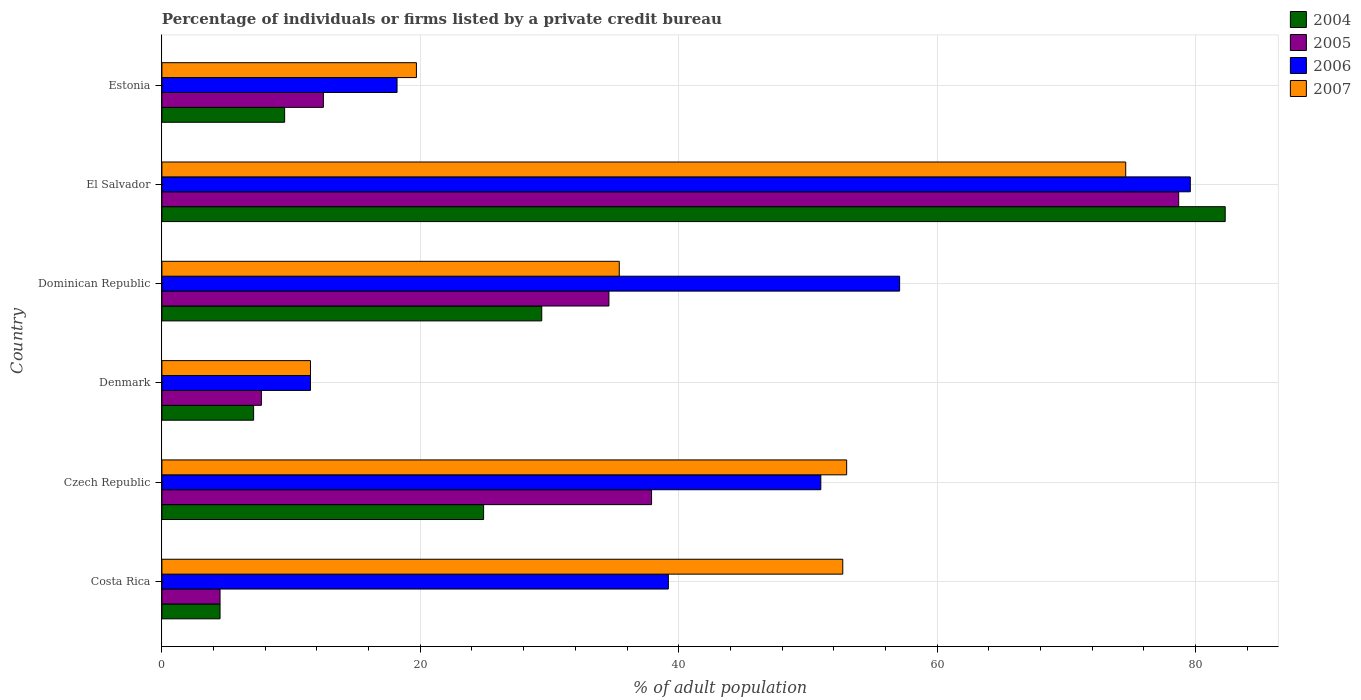Are the number of bars per tick equal to the number of legend labels?
Provide a short and direct response. Yes. How many bars are there on the 1st tick from the top?
Provide a short and direct response. 4. How many bars are there on the 4th tick from the bottom?
Give a very brief answer. 4. What is the label of the 4th group of bars from the top?
Your answer should be compact. Denmark. In how many cases, is the number of bars for a given country not equal to the number of legend labels?
Offer a very short reply. 0. What is the percentage of population listed by a private credit bureau in 2006 in Costa Rica?
Make the answer very short. 39.2. Across all countries, what is the maximum percentage of population listed by a private credit bureau in 2004?
Your response must be concise. 82.3. Across all countries, what is the minimum percentage of population listed by a private credit bureau in 2004?
Your answer should be compact. 4.5. In which country was the percentage of population listed by a private credit bureau in 2006 maximum?
Keep it short and to the point. El Salvador. What is the total percentage of population listed by a private credit bureau in 2004 in the graph?
Give a very brief answer. 157.7. What is the difference between the percentage of population listed by a private credit bureau in 2007 in Czech Republic and that in El Salvador?
Make the answer very short. -21.6. What is the difference between the percentage of population listed by a private credit bureau in 2006 in Dominican Republic and the percentage of population listed by a private credit bureau in 2004 in El Salvador?
Provide a short and direct response. -25.2. What is the average percentage of population listed by a private credit bureau in 2004 per country?
Your answer should be compact. 26.28. What is the ratio of the percentage of population listed by a private credit bureau in 2004 in Dominican Republic to that in Estonia?
Your response must be concise. 3.09. Is the percentage of population listed by a private credit bureau in 2005 in Costa Rica less than that in Czech Republic?
Offer a terse response. Yes. Is the difference between the percentage of population listed by a private credit bureau in 2007 in Denmark and El Salvador greater than the difference between the percentage of population listed by a private credit bureau in 2005 in Denmark and El Salvador?
Your answer should be very brief. Yes. What is the difference between the highest and the second highest percentage of population listed by a private credit bureau in 2007?
Keep it short and to the point. 21.6. What is the difference between the highest and the lowest percentage of population listed by a private credit bureau in 2005?
Provide a short and direct response. 74.2. In how many countries, is the percentage of population listed by a private credit bureau in 2006 greater than the average percentage of population listed by a private credit bureau in 2006 taken over all countries?
Give a very brief answer. 3. Is the sum of the percentage of population listed by a private credit bureau in 2007 in Costa Rica and Denmark greater than the maximum percentage of population listed by a private credit bureau in 2006 across all countries?
Ensure brevity in your answer.  No. Is it the case that in every country, the sum of the percentage of population listed by a private credit bureau in 2006 and percentage of population listed by a private credit bureau in 2004 is greater than the sum of percentage of population listed by a private credit bureau in 2005 and percentage of population listed by a private credit bureau in 2007?
Provide a succinct answer. No. What does the 2nd bar from the top in El Salvador represents?
Offer a terse response. 2006. What does the 2nd bar from the bottom in Czech Republic represents?
Keep it short and to the point. 2005. How many countries are there in the graph?
Give a very brief answer. 6. Does the graph contain grids?
Keep it short and to the point. Yes. Where does the legend appear in the graph?
Give a very brief answer. Top right. How many legend labels are there?
Your answer should be compact. 4. How are the legend labels stacked?
Provide a short and direct response. Vertical. What is the title of the graph?
Provide a succinct answer. Percentage of individuals or firms listed by a private credit bureau. Does "2000" appear as one of the legend labels in the graph?
Offer a terse response. No. What is the label or title of the X-axis?
Give a very brief answer. % of adult population. What is the % of adult population of 2004 in Costa Rica?
Your answer should be compact. 4.5. What is the % of adult population of 2005 in Costa Rica?
Ensure brevity in your answer.  4.5. What is the % of adult population in 2006 in Costa Rica?
Give a very brief answer. 39.2. What is the % of adult population in 2007 in Costa Rica?
Keep it short and to the point. 52.7. What is the % of adult population in 2004 in Czech Republic?
Your response must be concise. 24.9. What is the % of adult population in 2005 in Czech Republic?
Keep it short and to the point. 37.9. What is the % of adult population of 2006 in Czech Republic?
Provide a short and direct response. 51. What is the % of adult population in 2004 in Dominican Republic?
Offer a terse response. 29.4. What is the % of adult population in 2005 in Dominican Republic?
Give a very brief answer. 34.6. What is the % of adult population of 2006 in Dominican Republic?
Your answer should be compact. 57.1. What is the % of adult population of 2007 in Dominican Republic?
Keep it short and to the point. 35.4. What is the % of adult population of 2004 in El Salvador?
Provide a short and direct response. 82.3. What is the % of adult population in 2005 in El Salvador?
Give a very brief answer. 78.7. What is the % of adult population in 2006 in El Salvador?
Your answer should be very brief. 79.6. What is the % of adult population of 2007 in El Salvador?
Keep it short and to the point. 74.6. Across all countries, what is the maximum % of adult population in 2004?
Your answer should be compact. 82.3. Across all countries, what is the maximum % of adult population in 2005?
Your response must be concise. 78.7. Across all countries, what is the maximum % of adult population of 2006?
Your answer should be compact. 79.6. Across all countries, what is the maximum % of adult population of 2007?
Make the answer very short. 74.6. Across all countries, what is the minimum % of adult population of 2004?
Your answer should be compact. 4.5. Across all countries, what is the minimum % of adult population in 2006?
Provide a short and direct response. 11.5. Across all countries, what is the minimum % of adult population in 2007?
Ensure brevity in your answer.  11.5. What is the total % of adult population in 2004 in the graph?
Your response must be concise. 157.7. What is the total % of adult population in 2005 in the graph?
Provide a succinct answer. 175.9. What is the total % of adult population of 2006 in the graph?
Offer a very short reply. 256.6. What is the total % of adult population of 2007 in the graph?
Offer a terse response. 246.9. What is the difference between the % of adult population in 2004 in Costa Rica and that in Czech Republic?
Provide a short and direct response. -20.4. What is the difference between the % of adult population in 2005 in Costa Rica and that in Czech Republic?
Keep it short and to the point. -33.4. What is the difference between the % of adult population of 2006 in Costa Rica and that in Czech Republic?
Your answer should be very brief. -11.8. What is the difference between the % of adult population of 2007 in Costa Rica and that in Czech Republic?
Make the answer very short. -0.3. What is the difference between the % of adult population in 2006 in Costa Rica and that in Denmark?
Keep it short and to the point. 27.7. What is the difference between the % of adult population in 2007 in Costa Rica and that in Denmark?
Provide a succinct answer. 41.2. What is the difference between the % of adult population in 2004 in Costa Rica and that in Dominican Republic?
Provide a succinct answer. -24.9. What is the difference between the % of adult population in 2005 in Costa Rica and that in Dominican Republic?
Make the answer very short. -30.1. What is the difference between the % of adult population in 2006 in Costa Rica and that in Dominican Republic?
Make the answer very short. -17.9. What is the difference between the % of adult population in 2004 in Costa Rica and that in El Salvador?
Give a very brief answer. -77.8. What is the difference between the % of adult population of 2005 in Costa Rica and that in El Salvador?
Offer a very short reply. -74.2. What is the difference between the % of adult population in 2006 in Costa Rica and that in El Salvador?
Give a very brief answer. -40.4. What is the difference between the % of adult population of 2007 in Costa Rica and that in El Salvador?
Ensure brevity in your answer.  -21.9. What is the difference between the % of adult population of 2004 in Costa Rica and that in Estonia?
Ensure brevity in your answer.  -5. What is the difference between the % of adult population in 2005 in Costa Rica and that in Estonia?
Keep it short and to the point. -8. What is the difference between the % of adult population of 2006 in Costa Rica and that in Estonia?
Offer a terse response. 21. What is the difference between the % of adult population of 2007 in Costa Rica and that in Estonia?
Keep it short and to the point. 33. What is the difference between the % of adult population of 2005 in Czech Republic and that in Denmark?
Provide a succinct answer. 30.2. What is the difference between the % of adult population in 2006 in Czech Republic and that in Denmark?
Your answer should be compact. 39.5. What is the difference between the % of adult population in 2007 in Czech Republic and that in Denmark?
Provide a short and direct response. 41.5. What is the difference between the % of adult population of 2004 in Czech Republic and that in Dominican Republic?
Provide a succinct answer. -4.5. What is the difference between the % of adult population of 2005 in Czech Republic and that in Dominican Republic?
Make the answer very short. 3.3. What is the difference between the % of adult population in 2006 in Czech Republic and that in Dominican Republic?
Keep it short and to the point. -6.1. What is the difference between the % of adult population in 2007 in Czech Republic and that in Dominican Republic?
Your answer should be compact. 17.6. What is the difference between the % of adult population in 2004 in Czech Republic and that in El Salvador?
Your response must be concise. -57.4. What is the difference between the % of adult population in 2005 in Czech Republic and that in El Salvador?
Offer a terse response. -40.8. What is the difference between the % of adult population in 2006 in Czech Republic and that in El Salvador?
Offer a terse response. -28.6. What is the difference between the % of adult population of 2007 in Czech Republic and that in El Salvador?
Offer a very short reply. -21.6. What is the difference between the % of adult population of 2005 in Czech Republic and that in Estonia?
Your answer should be compact. 25.4. What is the difference between the % of adult population in 2006 in Czech Republic and that in Estonia?
Offer a very short reply. 32.8. What is the difference between the % of adult population in 2007 in Czech Republic and that in Estonia?
Make the answer very short. 33.3. What is the difference between the % of adult population of 2004 in Denmark and that in Dominican Republic?
Your response must be concise. -22.3. What is the difference between the % of adult population of 2005 in Denmark and that in Dominican Republic?
Your response must be concise. -26.9. What is the difference between the % of adult population of 2006 in Denmark and that in Dominican Republic?
Provide a short and direct response. -45.6. What is the difference between the % of adult population in 2007 in Denmark and that in Dominican Republic?
Provide a succinct answer. -23.9. What is the difference between the % of adult population of 2004 in Denmark and that in El Salvador?
Offer a very short reply. -75.2. What is the difference between the % of adult population of 2005 in Denmark and that in El Salvador?
Give a very brief answer. -71. What is the difference between the % of adult population of 2006 in Denmark and that in El Salvador?
Make the answer very short. -68.1. What is the difference between the % of adult population in 2007 in Denmark and that in El Salvador?
Provide a short and direct response. -63.1. What is the difference between the % of adult population of 2005 in Denmark and that in Estonia?
Your answer should be compact. -4.8. What is the difference between the % of adult population in 2006 in Denmark and that in Estonia?
Offer a terse response. -6.7. What is the difference between the % of adult population in 2007 in Denmark and that in Estonia?
Offer a terse response. -8.2. What is the difference between the % of adult population of 2004 in Dominican Republic and that in El Salvador?
Provide a short and direct response. -52.9. What is the difference between the % of adult population of 2005 in Dominican Republic and that in El Salvador?
Provide a succinct answer. -44.1. What is the difference between the % of adult population in 2006 in Dominican Republic and that in El Salvador?
Make the answer very short. -22.5. What is the difference between the % of adult population of 2007 in Dominican Republic and that in El Salvador?
Your answer should be very brief. -39.2. What is the difference between the % of adult population of 2005 in Dominican Republic and that in Estonia?
Provide a succinct answer. 22.1. What is the difference between the % of adult population of 2006 in Dominican Republic and that in Estonia?
Offer a very short reply. 38.9. What is the difference between the % of adult population of 2007 in Dominican Republic and that in Estonia?
Offer a terse response. 15.7. What is the difference between the % of adult population in 2004 in El Salvador and that in Estonia?
Keep it short and to the point. 72.8. What is the difference between the % of adult population in 2005 in El Salvador and that in Estonia?
Your answer should be very brief. 66.2. What is the difference between the % of adult population in 2006 in El Salvador and that in Estonia?
Ensure brevity in your answer.  61.4. What is the difference between the % of adult population of 2007 in El Salvador and that in Estonia?
Give a very brief answer. 54.9. What is the difference between the % of adult population of 2004 in Costa Rica and the % of adult population of 2005 in Czech Republic?
Your answer should be compact. -33.4. What is the difference between the % of adult population in 2004 in Costa Rica and the % of adult population in 2006 in Czech Republic?
Make the answer very short. -46.5. What is the difference between the % of adult population in 2004 in Costa Rica and the % of adult population in 2007 in Czech Republic?
Your answer should be very brief. -48.5. What is the difference between the % of adult population in 2005 in Costa Rica and the % of adult population in 2006 in Czech Republic?
Offer a very short reply. -46.5. What is the difference between the % of adult population in 2005 in Costa Rica and the % of adult population in 2007 in Czech Republic?
Provide a short and direct response. -48.5. What is the difference between the % of adult population of 2006 in Costa Rica and the % of adult population of 2007 in Czech Republic?
Your response must be concise. -13.8. What is the difference between the % of adult population of 2004 in Costa Rica and the % of adult population of 2005 in Denmark?
Ensure brevity in your answer.  -3.2. What is the difference between the % of adult population in 2004 in Costa Rica and the % of adult population in 2006 in Denmark?
Provide a succinct answer. -7. What is the difference between the % of adult population in 2004 in Costa Rica and the % of adult population in 2007 in Denmark?
Make the answer very short. -7. What is the difference between the % of adult population of 2005 in Costa Rica and the % of adult population of 2006 in Denmark?
Keep it short and to the point. -7. What is the difference between the % of adult population of 2006 in Costa Rica and the % of adult population of 2007 in Denmark?
Keep it short and to the point. 27.7. What is the difference between the % of adult population in 2004 in Costa Rica and the % of adult population in 2005 in Dominican Republic?
Provide a succinct answer. -30.1. What is the difference between the % of adult population of 2004 in Costa Rica and the % of adult population of 2006 in Dominican Republic?
Ensure brevity in your answer.  -52.6. What is the difference between the % of adult population in 2004 in Costa Rica and the % of adult population in 2007 in Dominican Republic?
Provide a short and direct response. -30.9. What is the difference between the % of adult population in 2005 in Costa Rica and the % of adult population in 2006 in Dominican Republic?
Ensure brevity in your answer.  -52.6. What is the difference between the % of adult population of 2005 in Costa Rica and the % of adult population of 2007 in Dominican Republic?
Give a very brief answer. -30.9. What is the difference between the % of adult population of 2004 in Costa Rica and the % of adult population of 2005 in El Salvador?
Give a very brief answer. -74.2. What is the difference between the % of adult population in 2004 in Costa Rica and the % of adult population in 2006 in El Salvador?
Provide a succinct answer. -75.1. What is the difference between the % of adult population in 2004 in Costa Rica and the % of adult population in 2007 in El Salvador?
Keep it short and to the point. -70.1. What is the difference between the % of adult population of 2005 in Costa Rica and the % of adult population of 2006 in El Salvador?
Give a very brief answer. -75.1. What is the difference between the % of adult population of 2005 in Costa Rica and the % of adult population of 2007 in El Salvador?
Make the answer very short. -70.1. What is the difference between the % of adult population in 2006 in Costa Rica and the % of adult population in 2007 in El Salvador?
Ensure brevity in your answer.  -35.4. What is the difference between the % of adult population in 2004 in Costa Rica and the % of adult population in 2005 in Estonia?
Give a very brief answer. -8. What is the difference between the % of adult population in 2004 in Costa Rica and the % of adult population in 2006 in Estonia?
Ensure brevity in your answer.  -13.7. What is the difference between the % of adult population in 2004 in Costa Rica and the % of adult population in 2007 in Estonia?
Your response must be concise. -15.2. What is the difference between the % of adult population of 2005 in Costa Rica and the % of adult population of 2006 in Estonia?
Provide a succinct answer. -13.7. What is the difference between the % of adult population of 2005 in Costa Rica and the % of adult population of 2007 in Estonia?
Your response must be concise. -15.2. What is the difference between the % of adult population of 2006 in Costa Rica and the % of adult population of 2007 in Estonia?
Provide a short and direct response. 19.5. What is the difference between the % of adult population in 2004 in Czech Republic and the % of adult population in 2005 in Denmark?
Provide a short and direct response. 17.2. What is the difference between the % of adult population in 2004 in Czech Republic and the % of adult population in 2006 in Denmark?
Ensure brevity in your answer.  13.4. What is the difference between the % of adult population in 2004 in Czech Republic and the % of adult population in 2007 in Denmark?
Offer a very short reply. 13.4. What is the difference between the % of adult population in 2005 in Czech Republic and the % of adult population in 2006 in Denmark?
Provide a short and direct response. 26.4. What is the difference between the % of adult population in 2005 in Czech Republic and the % of adult population in 2007 in Denmark?
Provide a short and direct response. 26.4. What is the difference between the % of adult population in 2006 in Czech Republic and the % of adult population in 2007 in Denmark?
Offer a terse response. 39.5. What is the difference between the % of adult population in 2004 in Czech Republic and the % of adult population in 2005 in Dominican Republic?
Your answer should be very brief. -9.7. What is the difference between the % of adult population in 2004 in Czech Republic and the % of adult population in 2006 in Dominican Republic?
Provide a succinct answer. -32.2. What is the difference between the % of adult population in 2004 in Czech Republic and the % of adult population in 2007 in Dominican Republic?
Provide a succinct answer. -10.5. What is the difference between the % of adult population in 2005 in Czech Republic and the % of adult population in 2006 in Dominican Republic?
Offer a very short reply. -19.2. What is the difference between the % of adult population of 2006 in Czech Republic and the % of adult population of 2007 in Dominican Republic?
Give a very brief answer. 15.6. What is the difference between the % of adult population in 2004 in Czech Republic and the % of adult population in 2005 in El Salvador?
Give a very brief answer. -53.8. What is the difference between the % of adult population in 2004 in Czech Republic and the % of adult population in 2006 in El Salvador?
Your response must be concise. -54.7. What is the difference between the % of adult population of 2004 in Czech Republic and the % of adult population of 2007 in El Salvador?
Your answer should be compact. -49.7. What is the difference between the % of adult population of 2005 in Czech Republic and the % of adult population of 2006 in El Salvador?
Offer a very short reply. -41.7. What is the difference between the % of adult population of 2005 in Czech Republic and the % of adult population of 2007 in El Salvador?
Your answer should be very brief. -36.7. What is the difference between the % of adult population of 2006 in Czech Republic and the % of adult population of 2007 in El Salvador?
Provide a short and direct response. -23.6. What is the difference between the % of adult population of 2004 in Czech Republic and the % of adult population of 2005 in Estonia?
Ensure brevity in your answer.  12.4. What is the difference between the % of adult population in 2004 in Czech Republic and the % of adult population in 2007 in Estonia?
Your response must be concise. 5.2. What is the difference between the % of adult population in 2005 in Czech Republic and the % of adult population in 2006 in Estonia?
Give a very brief answer. 19.7. What is the difference between the % of adult population in 2006 in Czech Republic and the % of adult population in 2007 in Estonia?
Offer a terse response. 31.3. What is the difference between the % of adult population of 2004 in Denmark and the % of adult population of 2005 in Dominican Republic?
Your response must be concise. -27.5. What is the difference between the % of adult population in 2004 in Denmark and the % of adult population in 2007 in Dominican Republic?
Offer a very short reply. -28.3. What is the difference between the % of adult population of 2005 in Denmark and the % of adult population of 2006 in Dominican Republic?
Make the answer very short. -49.4. What is the difference between the % of adult population in 2005 in Denmark and the % of adult population in 2007 in Dominican Republic?
Give a very brief answer. -27.7. What is the difference between the % of adult population of 2006 in Denmark and the % of adult population of 2007 in Dominican Republic?
Ensure brevity in your answer.  -23.9. What is the difference between the % of adult population in 2004 in Denmark and the % of adult population in 2005 in El Salvador?
Keep it short and to the point. -71.6. What is the difference between the % of adult population of 2004 in Denmark and the % of adult population of 2006 in El Salvador?
Make the answer very short. -72.5. What is the difference between the % of adult population of 2004 in Denmark and the % of adult population of 2007 in El Salvador?
Ensure brevity in your answer.  -67.5. What is the difference between the % of adult population of 2005 in Denmark and the % of adult population of 2006 in El Salvador?
Make the answer very short. -71.9. What is the difference between the % of adult population of 2005 in Denmark and the % of adult population of 2007 in El Salvador?
Offer a very short reply. -66.9. What is the difference between the % of adult population in 2006 in Denmark and the % of adult population in 2007 in El Salvador?
Make the answer very short. -63.1. What is the difference between the % of adult population in 2005 in Denmark and the % of adult population in 2006 in Estonia?
Your response must be concise. -10.5. What is the difference between the % of adult population in 2005 in Denmark and the % of adult population in 2007 in Estonia?
Offer a very short reply. -12. What is the difference between the % of adult population in 2006 in Denmark and the % of adult population in 2007 in Estonia?
Offer a terse response. -8.2. What is the difference between the % of adult population in 2004 in Dominican Republic and the % of adult population in 2005 in El Salvador?
Provide a succinct answer. -49.3. What is the difference between the % of adult population in 2004 in Dominican Republic and the % of adult population in 2006 in El Salvador?
Provide a succinct answer. -50.2. What is the difference between the % of adult population of 2004 in Dominican Republic and the % of adult population of 2007 in El Salvador?
Your answer should be very brief. -45.2. What is the difference between the % of adult population in 2005 in Dominican Republic and the % of adult population in 2006 in El Salvador?
Make the answer very short. -45. What is the difference between the % of adult population of 2005 in Dominican Republic and the % of adult population of 2007 in El Salvador?
Offer a terse response. -40. What is the difference between the % of adult population in 2006 in Dominican Republic and the % of adult population in 2007 in El Salvador?
Make the answer very short. -17.5. What is the difference between the % of adult population in 2004 in Dominican Republic and the % of adult population in 2005 in Estonia?
Offer a very short reply. 16.9. What is the difference between the % of adult population of 2004 in Dominican Republic and the % of adult population of 2007 in Estonia?
Provide a succinct answer. 9.7. What is the difference between the % of adult population of 2006 in Dominican Republic and the % of adult population of 2007 in Estonia?
Your answer should be very brief. 37.4. What is the difference between the % of adult population in 2004 in El Salvador and the % of adult population in 2005 in Estonia?
Provide a succinct answer. 69.8. What is the difference between the % of adult population in 2004 in El Salvador and the % of adult population in 2006 in Estonia?
Your answer should be compact. 64.1. What is the difference between the % of adult population in 2004 in El Salvador and the % of adult population in 2007 in Estonia?
Provide a succinct answer. 62.6. What is the difference between the % of adult population of 2005 in El Salvador and the % of adult population of 2006 in Estonia?
Make the answer very short. 60.5. What is the difference between the % of adult population of 2006 in El Salvador and the % of adult population of 2007 in Estonia?
Give a very brief answer. 59.9. What is the average % of adult population of 2004 per country?
Provide a succinct answer. 26.28. What is the average % of adult population of 2005 per country?
Make the answer very short. 29.32. What is the average % of adult population of 2006 per country?
Your answer should be very brief. 42.77. What is the average % of adult population in 2007 per country?
Provide a short and direct response. 41.15. What is the difference between the % of adult population of 2004 and % of adult population of 2006 in Costa Rica?
Provide a succinct answer. -34.7. What is the difference between the % of adult population in 2004 and % of adult population in 2007 in Costa Rica?
Ensure brevity in your answer.  -48.2. What is the difference between the % of adult population of 2005 and % of adult population of 2006 in Costa Rica?
Provide a succinct answer. -34.7. What is the difference between the % of adult population of 2005 and % of adult population of 2007 in Costa Rica?
Keep it short and to the point. -48.2. What is the difference between the % of adult population in 2006 and % of adult population in 2007 in Costa Rica?
Make the answer very short. -13.5. What is the difference between the % of adult population in 2004 and % of adult population in 2006 in Czech Republic?
Offer a very short reply. -26.1. What is the difference between the % of adult population in 2004 and % of adult population in 2007 in Czech Republic?
Provide a short and direct response. -28.1. What is the difference between the % of adult population of 2005 and % of adult population of 2006 in Czech Republic?
Your answer should be very brief. -13.1. What is the difference between the % of adult population in 2005 and % of adult population in 2007 in Czech Republic?
Provide a succinct answer. -15.1. What is the difference between the % of adult population of 2005 and % of adult population of 2006 in Denmark?
Provide a succinct answer. -3.8. What is the difference between the % of adult population of 2005 and % of adult population of 2007 in Denmark?
Your response must be concise. -3.8. What is the difference between the % of adult population of 2006 and % of adult population of 2007 in Denmark?
Provide a short and direct response. 0. What is the difference between the % of adult population in 2004 and % of adult population in 2006 in Dominican Republic?
Your answer should be very brief. -27.7. What is the difference between the % of adult population in 2004 and % of adult population in 2007 in Dominican Republic?
Your answer should be compact. -6. What is the difference between the % of adult population of 2005 and % of adult population of 2006 in Dominican Republic?
Provide a short and direct response. -22.5. What is the difference between the % of adult population of 2005 and % of adult population of 2007 in Dominican Republic?
Your answer should be compact. -0.8. What is the difference between the % of adult population of 2006 and % of adult population of 2007 in Dominican Republic?
Provide a succinct answer. 21.7. What is the difference between the % of adult population of 2004 and % of adult population of 2005 in El Salvador?
Offer a very short reply. 3.6. What is the difference between the % of adult population of 2004 and % of adult population of 2007 in El Salvador?
Offer a terse response. 7.7. What is the difference between the % of adult population of 2005 and % of adult population of 2006 in El Salvador?
Offer a terse response. -0.9. What is the difference between the % of adult population in 2004 and % of adult population in 2005 in Estonia?
Give a very brief answer. -3. What is the difference between the % of adult population of 2004 and % of adult population of 2007 in Estonia?
Provide a succinct answer. -10.2. What is the difference between the % of adult population of 2005 and % of adult population of 2007 in Estonia?
Provide a succinct answer. -7.2. What is the ratio of the % of adult population of 2004 in Costa Rica to that in Czech Republic?
Make the answer very short. 0.18. What is the ratio of the % of adult population in 2005 in Costa Rica to that in Czech Republic?
Offer a terse response. 0.12. What is the ratio of the % of adult population in 2006 in Costa Rica to that in Czech Republic?
Provide a succinct answer. 0.77. What is the ratio of the % of adult population of 2004 in Costa Rica to that in Denmark?
Give a very brief answer. 0.63. What is the ratio of the % of adult population in 2005 in Costa Rica to that in Denmark?
Your answer should be very brief. 0.58. What is the ratio of the % of adult population of 2006 in Costa Rica to that in Denmark?
Your response must be concise. 3.41. What is the ratio of the % of adult population of 2007 in Costa Rica to that in Denmark?
Keep it short and to the point. 4.58. What is the ratio of the % of adult population of 2004 in Costa Rica to that in Dominican Republic?
Keep it short and to the point. 0.15. What is the ratio of the % of adult population of 2005 in Costa Rica to that in Dominican Republic?
Offer a very short reply. 0.13. What is the ratio of the % of adult population in 2006 in Costa Rica to that in Dominican Republic?
Ensure brevity in your answer.  0.69. What is the ratio of the % of adult population of 2007 in Costa Rica to that in Dominican Republic?
Ensure brevity in your answer.  1.49. What is the ratio of the % of adult population of 2004 in Costa Rica to that in El Salvador?
Your answer should be compact. 0.05. What is the ratio of the % of adult population in 2005 in Costa Rica to that in El Salvador?
Make the answer very short. 0.06. What is the ratio of the % of adult population of 2006 in Costa Rica to that in El Salvador?
Make the answer very short. 0.49. What is the ratio of the % of adult population of 2007 in Costa Rica to that in El Salvador?
Keep it short and to the point. 0.71. What is the ratio of the % of adult population of 2004 in Costa Rica to that in Estonia?
Provide a short and direct response. 0.47. What is the ratio of the % of adult population of 2005 in Costa Rica to that in Estonia?
Keep it short and to the point. 0.36. What is the ratio of the % of adult population in 2006 in Costa Rica to that in Estonia?
Ensure brevity in your answer.  2.15. What is the ratio of the % of adult population in 2007 in Costa Rica to that in Estonia?
Keep it short and to the point. 2.68. What is the ratio of the % of adult population in 2004 in Czech Republic to that in Denmark?
Your answer should be very brief. 3.51. What is the ratio of the % of adult population in 2005 in Czech Republic to that in Denmark?
Ensure brevity in your answer.  4.92. What is the ratio of the % of adult population of 2006 in Czech Republic to that in Denmark?
Keep it short and to the point. 4.43. What is the ratio of the % of adult population in 2007 in Czech Republic to that in Denmark?
Offer a very short reply. 4.61. What is the ratio of the % of adult population in 2004 in Czech Republic to that in Dominican Republic?
Provide a short and direct response. 0.85. What is the ratio of the % of adult population of 2005 in Czech Republic to that in Dominican Republic?
Your answer should be very brief. 1.1. What is the ratio of the % of adult population in 2006 in Czech Republic to that in Dominican Republic?
Ensure brevity in your answer.  0.89. What is the ratio of the % of adult population in 2007 in Czech Republic to that in Dominican Republic?
Your answer should be very brief. 1.5. What is the ratio of the % of adult population in 2004 in Czech Republic to that in El Salvador?
Offer a terse response. 0.3. What is the ratio of the % of adult population of 2005 in Czech Republic to that in El Salvador?
Give a very brief answer. 0.48. What is the ratio of the % of adult population in 2006 in Czech Republic to that in El Salvador?
Your response must be concise. 0.64. What is the ratio of the % of adult population of 2007 in Czech Republic to that in El Salvador?
Offer a terse response. 0.71. What is the ratio of the % of adult population of 2004 in Czech Republic to that in Estonia?
Make the answer very short. 2.62. What is the ratio of the % of adult population in 2005 in Czech Republic to that in Estonia?
Make the answer very short. 3.03. What is the ratio of the % of adult population in 2006 in Czech Republic to that in Estonia?
Offer a terse response. 2.8. What is the ratio of the % of adult population in 2007 in Czech Republic to that in Estonia?
Give a very brief answer. 2.69. What is the ratio of the % of adult population of 2004 in Denmark to that in Dominican Republic?
Provide a short and direct response. 0.24. What is the ratio of the % of adult population of 2005 in Denmark to that in Dominican Republic?
Your answer should be very brief. 0.22. What is the ratio of the % of adult population in 2006 in Denmark to that in Dominican Republic?
Ensure brevity in your answer.  0.2. What is the ratio of the % of adult population of 2007 in Denmark to that in Dominican Republic?
Ensure brevity in your answer.  0.32. What is the ratio of the % of adult population in 2004 in Denmark to that in El Salvador?
Give a very brief answer. 0.09. What is the ratio of the % of adult population in 2005 in Denmark to that in El Salvador?
Offer a terse response. 0.1. What is the ratio of the % of adult population in 2006 in Denmark to that in El Salvador?
Give a very brief answer. 0.14. What is the ratio of the % of adult population in 2007 in Denmark to that in El Salvador?
Keep it short and to the point. 0.15. What is the ratio of the % of adult population in 2004 in Denmark to that in Estonia?
Offer a terse response. 0.75. What is the ratio of the % of adult population in 2005 in Denmark to that in Estonia?
Your response must be concise. 0.62. What is the ratio of the % of adult population in 2006 in Denmark to that in Estonia?
Your response must be concise. 0.63. What is the ratio of the % of adult population of 2007 in Denmark to that in Estonia?
Make the answer very short. 0.58. What is the ratio of the % of adult population in 2004 in Dominican Republic to that in El Salvador?
Ensure brevity in your answer.  0.36. What is the ratio of the % of adult population of 2005 in Dominican Republic to that in El Salvador?
Provide a succinct answer. 0.44. What is the ratio of the % of adult population in 2006 in Dominican Republic to that in El Salvador?
Keep it short and to the point. 0.72. What is the ratio of the % of adult population of 2007 in Dominican Republic to that in El Salvador?
Offer a terse response. 0.47. What is the ratio of the % of adult population in 2004 in Dominican Republic to that in Estonia?
Make the answer very short. 3.09. What is the ratio of the % of adult population of 2005 in Dominican Republic to that in Estonia?
Your response must be concise. 2.77. What is the ratio of the % of adult population of 2006 in Dominican Republic to that in Estonia?
Keep it short and to the point. 3.14. What is the ratio of the % of adult population in 2007 in Dominican Republic to that in Estonia?
Your answer should be compact. 1.8. What is the ratio of the % of adult population in 2004 in El Salvador to that in Estonia?
Your answer should be compact. 8.66. What is the ratio of the % of adult population of 2005 in El Salvador to that in Estonia?
Make the answer very short. 6.3. What is the ratio of the % of adult population of 2006 in El Salvador to that in Estonia?
Your answer should be compact. 4.37. What is the ratio of the % of adult population in 2007 in El Salvador to that in Estonia?
Keep it short and to the point. 3.79. What is the difference between the highest and the second highest % of adult population of 2004?
Your answer should be compact. 52.9. What is the difference between the highest and the second highest % of adult population in 2005?
Your response must be concise. 40.8. What is the difference between the highest and the second highest % of adult population of 2006?
Offer a terse response. 22.5. What is the difference between the highest and the second highest % of adult population in 2007?
Provide a short and direct response. 21.6. What is the difference between the highest and the lowest % of adult population of 2004?
Make the answer very short. 77.8. What is the difference between the highest and the lowest % of adult population in 2005?
Offer a very short reply. 74.2. What is the difference between the highest and the lowest % of adult population of 2006?
Make the answer very short. 68.1. What is the difference between the highest and the lowest % of adult population of 2007?
Your response must be concise. 63.1. 